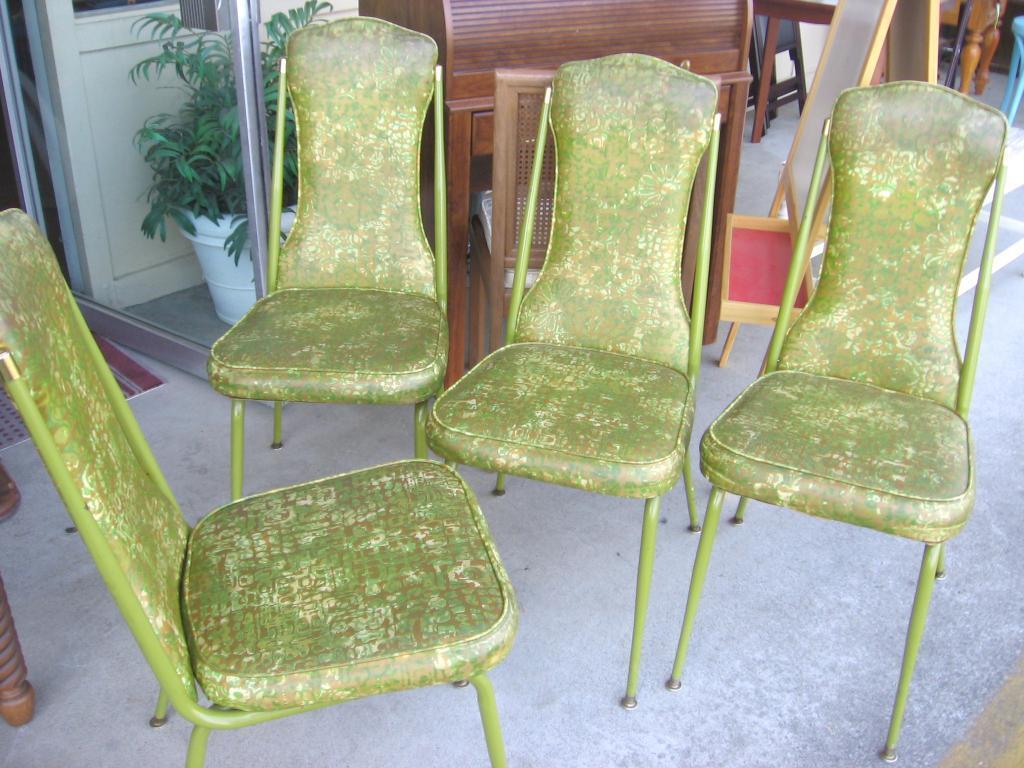In one or two sentences, can you explain what this image depicts? In this image we can see chairs. In the back there is a wooden object. Also there is a pot with plant. And there are boards with stand. In the background there are few other objects. 